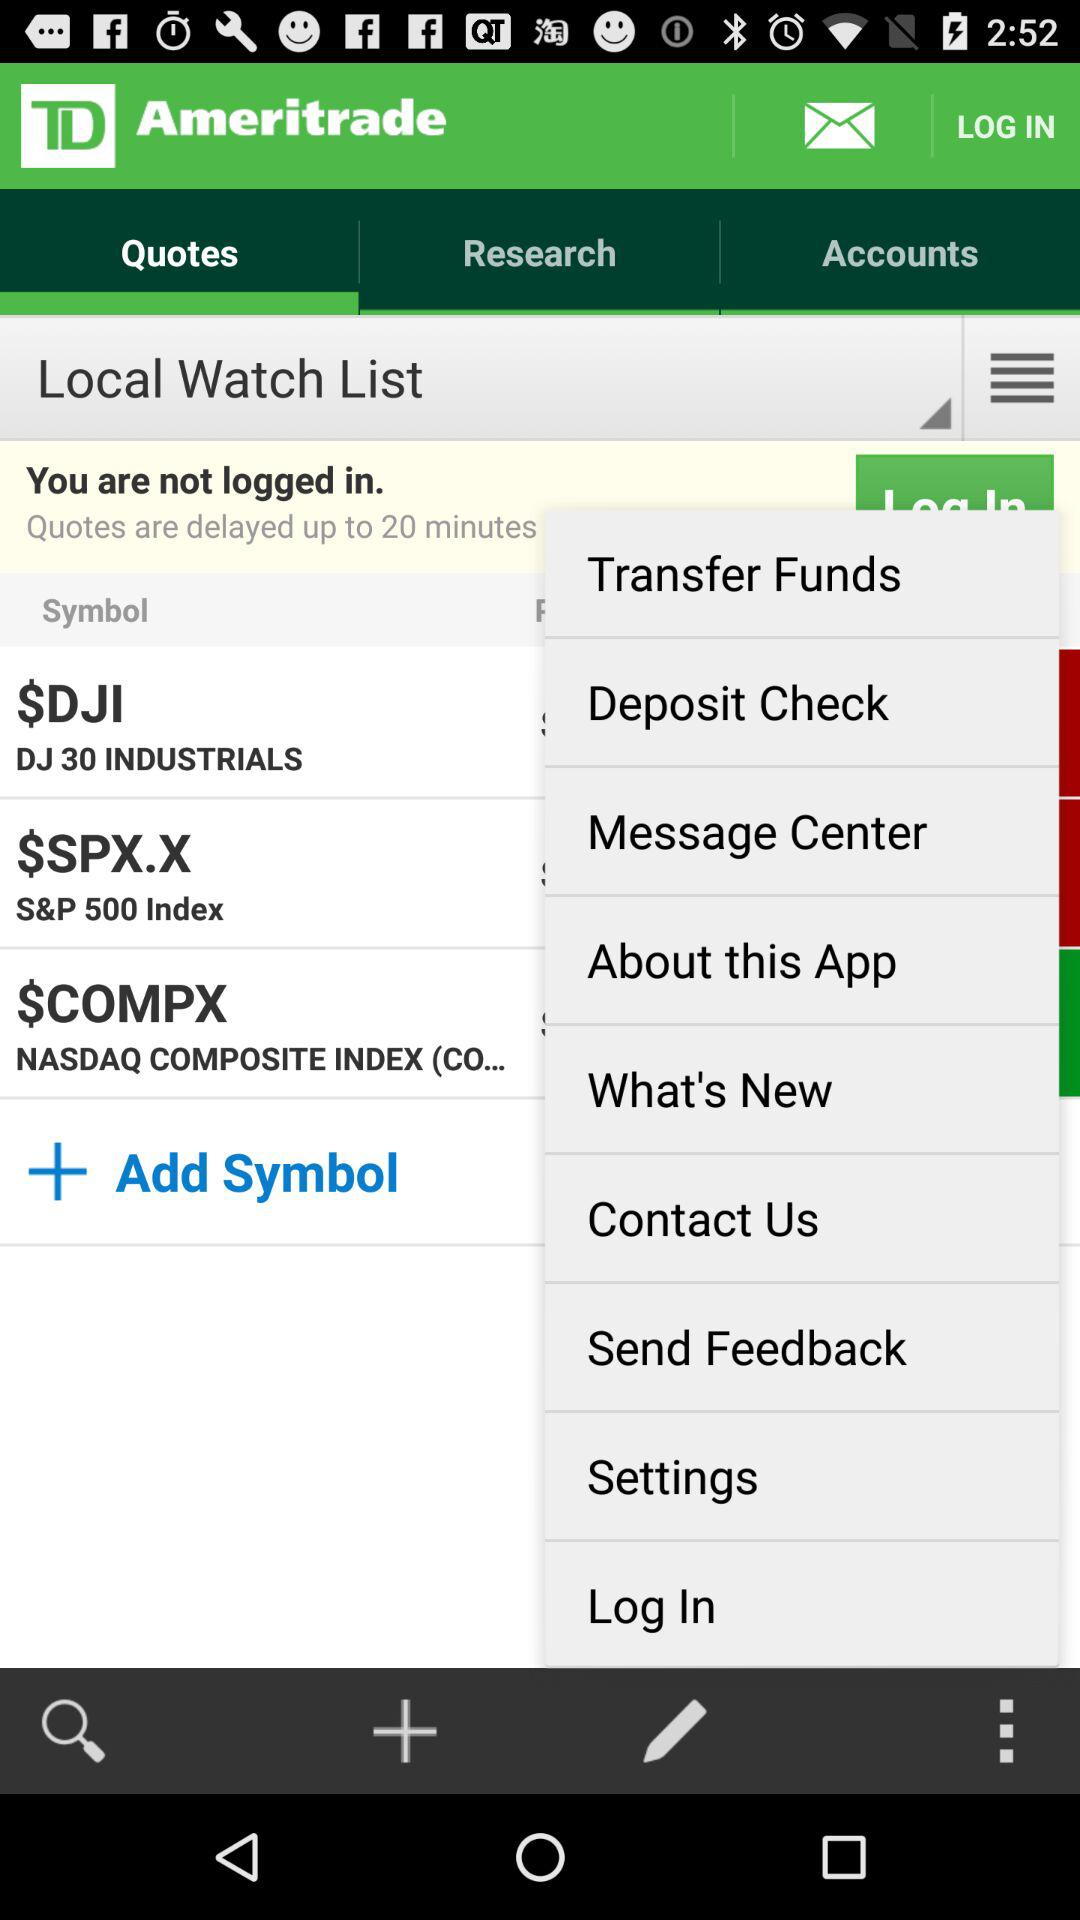What is the name of the application? The name of the application is "TD Ameritrade". 